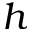Convert formula to latex. <formula><loc_0><loc_0><loc_500><loc_500>h</formula> 